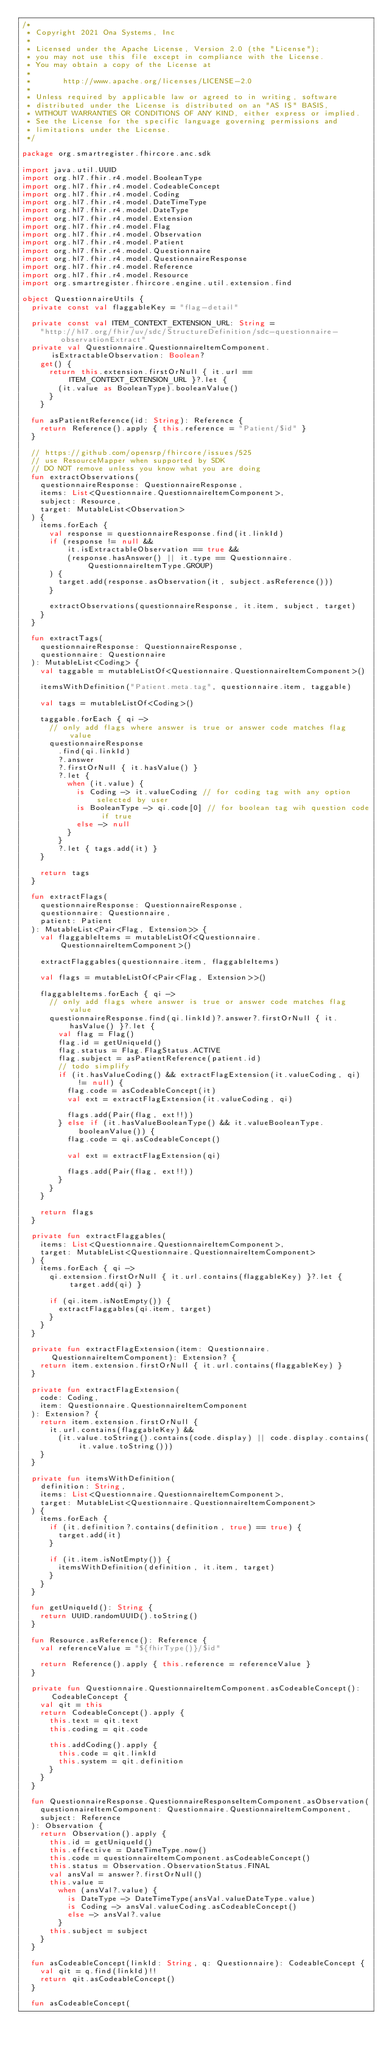Convert code to text. <code><loc_0><loc_0><loc_500><loc_500><_Kotlin_>/*
 * Copyright 2021 Ona Systems, Inc
 *
 * Licensed under the Apache License, Version 2.0 (the "License");
 * you may not use this file except in compliance with the License.
 * You may obtain a copy of the License at
 *
 *       http://www.apache.org/licenses/LICENSE-2.0
 *
 * Unless required by applicable law or agreed to in writing, software
 * distributed under the License is distributed on an "AS IS" BASIS,
 * WITHOUT WARRANTIES OR CONDITIONS OF ANY KIND, either express or implied.
 * See the License for the specific language governing permissions and
 * limitations under the License.
 */

package org.smartregister.fhircore.anc.sdk

import java.util.UUID
import org.hl7.fhir.r4.model.BooleanType
import org.hl7.fhir.r4.model.CodeableConcept
import org.hl7.fhir.r4.model.Coding
import org.hl7.fhir.r4.model.DateTimeType
import org.hl7.fhir.r4.model.DateType
import org.hl7.fhir.r4.model.Extension
import org.hl7.fhir.r4.model.Flag
import org.hl7.fhir.r4.model.Observation
import org.hl7.fhir.r4.model.Patient
import org.hl7.fhir.r4.model.Questionnaire
import org.hl7.fhir.r4.model.QuestionnaireResponse
import org.hl7.fhir.r4.model.Reference
import org.hl7.fhir.r4.model.Resource
import org.smartregister.fhircore.engine.util.extension.find

object QuestionnaireUtils {
  private const val flaggableKey = "flag-detail"

  private const val ITEM_CONTEXT_EXTENSION_URL: String =
    "http://hl7.org/fhir/uv/sdc/StructureDefinition/sdc-questionnaire-observationExtract"
  private val Questionnaire.QuestionnaireItemComponent.isExtractableObservation: Boolean?
    get() {
      return this.extension.firstOrNull { it.url == ITEM_CONTEXT_EXTENSION_URL }?.let {
        (it.value as BooleanType).booleanValue()
      }
    }

  fun asPatientReference(id: String): Reference {
    return Reference().apply { this.reference = "Patient/$id" }
  }

  // https://github.com/opensrp/fhircore/issues/525
  // use ResourceMapper when supported by SDK
  // DO NOT remove unless you know what you are doing
  fun extractObservations(
    questionnaireResponse: QuestionnaireResponse,
    items: List<Questionnaire.QuestionnaireItemComponent>,
    subject: Resource,
    target: MutableList<Observation>
  ) {
    items.forEach {
      val response = questionnaireResponse.find(it.linkId)
      if (response != null &&
          it.isExtractableObservation == true &&
          (response.hasAnswer() || it.type == Questionnaire.QuestionnaireItemType.GROUP)
      ) {
        target.add(response.asObservation(it, subject.asReference()))
      }

      extractObservations(questionnaireResponse, it.item, subject, target)
    }
  }

  fun extractTags(
    questionnaireResponse: QuestionnaireResponse,
    questionnaire: Questionnaire
  ): MutableList<Coding> {
    val taggable = mutableListOf<Questionnaire.QuestionnaireItemComponent>()

    itemsWithDefinition("Patient.meta.tag", questionnaire.item, taggable)

    val tags = mutableListOf<Coding>()

    taggable.forEach { qi ->
      // only add flags where answer is true or answer code matches flag value
      questionnaireResponse
        .find(qi.linkId)
        ?.answer
        ?.firstOrNull { it.hasValue() }
        ?.let {
          when (it.value) {
            is Coding -> it.valueCoding // for coding tag with any option selected by user
            is BooleanType -> qi.code[0] // for boolean tag wih question code if true
            else -> null
          }
        }
        ?.let { tags.add(it) }
    }

    return tags
  }

  fun extractFlags(
    questionnaireResponse: QuestionnaireResponse,
    questionnaire: Questionnaire,
    patient: Patient
  ): MutableList<Pair<Flag, Extension>> {
    val flaggableItems = mutableListOf<Questionnaire.QuestionnaireItemComponent>()

    extractFlaggables(questionnaire.item, flaggableItems)

    val flags = mutableListOf<Pair<Flag, Extension>>()

    flaggableItems.forEach { qi ->
      // only add flags where answer is true or answer code matches flag value
      questionnaireResponse.find(qi.linkId)?.answer?.firstOrNull { it.hasValue() }?.let {
        val flag = Flag()
        flag.id = getUniqueId()
        flag.status = Flag.FlagStatus.ACTIVE
        flag.subject = asPatientReference(patient.id)
        // todo simplify
        if (it.hasValueCoding() && extractFlagExtension(it.valueCoding, qi) != null) {
          flag.code = asCodeableConcept(it)
          val ext = extractFlagExtension(it.valueCoding, qi)

          flags.add(Pair(flag, ext!!))
        } else if (it.hasValueBooleanType() && it.valueBooleanType.booleanValue()) {
          flag.code = qi.asCodeableConcept()

          val ext = extractFlagExtension(qi)

          flags.add(Pair(flag, ext!!))
        }
      }
    }

    return flags
  }

  private fun extractFlaggables(
    items: List<Questionnaire.QuestionnaireItemComponent>,
    target: MutableList<Questionnaire.QuestionnaireItemComponent>
  ) {
    items.forEach { qi ->
      qi.extension.firstOrNull { it.url.contains(flaggableKey) }?.let { target.add(qi) }

      if (qi.item.isNotEmpty()) {
        extractFlaggables(qi.item, target)
      }
    }
  }

  private fun extractFlagExtension(item: Questionnaire.QuestionnaireItemComponent): Extension? {
    return item.extension.firstOrNull { it.url.contains(flaggableKey) }
  }

  private fun extractFlagExtension(
    code: Coding,
    item: Questionnaire.QuestionnaireItemComponent
  ): Extension? {
    return item.extension.firstOrNull {
      it.url.contains(flaggableKey) &&
        (it.value.toString().contains(code.display) || code.display.contains(it.value.toString()))
    }
  }

  private fun itemsWithDefinition(
    definition: String,
    items: List<Questionnaire.QuestionnaireItemComponent>,
    target: MutableList<Questionnaire.QuestionnaireItemComponent>
  ) {
    items.forEach {
      if (it.definition?.contains(definition, true) == true) {
        target.add(it)
      }

      if (it.item.isNotEmpty()) {
        itemsWithDefinition(definition, it.item, target)
      }
    }
  }

  fun getUniqueId(): String {
    return UUID.randomUUID().toString()
  }

  fun Resource.asReference(): Reference {
    val referenceValue = "${fhirType()}/$id"

    return Reference().apply { this.reference = referenceValue }
  }

  private fun Questionnaire.QuestionnaireItemComponent.asCodeableConcept(): CodeableConcept {
    val qit = this
    return CodeableConcept().apply {
      this.text = qit.text
      this.coding = qit.code

      this.addCoding().apply {
        this.code = qit.linkId
        this.system = qit.definition
      }
    }
  }

  fun QuestionnaireResponse.QuestionnaireResponseItemComponent.asObservation(
    questionnaireItemComponent: Questionnaire.QuestionnaireItemComponent,
    subject: Reference
  ): Observation {
    return Observation().apply {
      this.id = getUniqueId()
      this.effective = DateTimeType.now()
      this.code = questionnaireItemComponent.asCodeableConcept()
      this.status = Observation.ObservationStatus.FINAL
      val ansVal = answer?.firstOrNull()
      this.value =
        when (ansVal?.value) {
          is DateType -> DateTimeType(ansVal.valueDateType.value)
          is Coding -> ansVal.valueCoding.asCodeableConcept()
          else -> ansVal?.value
        }
      this.subject = subject
    }
  }

  fun asCodeableConcept(linkId: String, q: Questionnaire): CodeableConcept {
    val qit = q.find(linkId)!!
    return qit.asCodeableConcept()
  }

  fun asCodeableConcept(</code> 